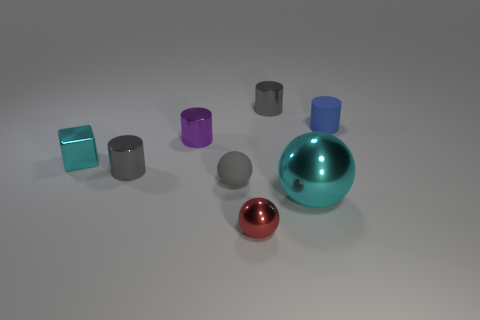Subtract 1 cylinders. How many cylinders are left? 3 Add 1 small gray matte objects. How many objects exist? 9 Subtract all balls. How many objects are left? 5 Add 5 small matte objects. How many small matte objects exist? 7 Subtract 1 gray balls. How many objects are left? 7 Subtract all big gray shiny blocks. Subtract all tiny metallic things. How many objects are left? 3 Add 4 tiny blue objects. How many tiny blue objects are left? 5 